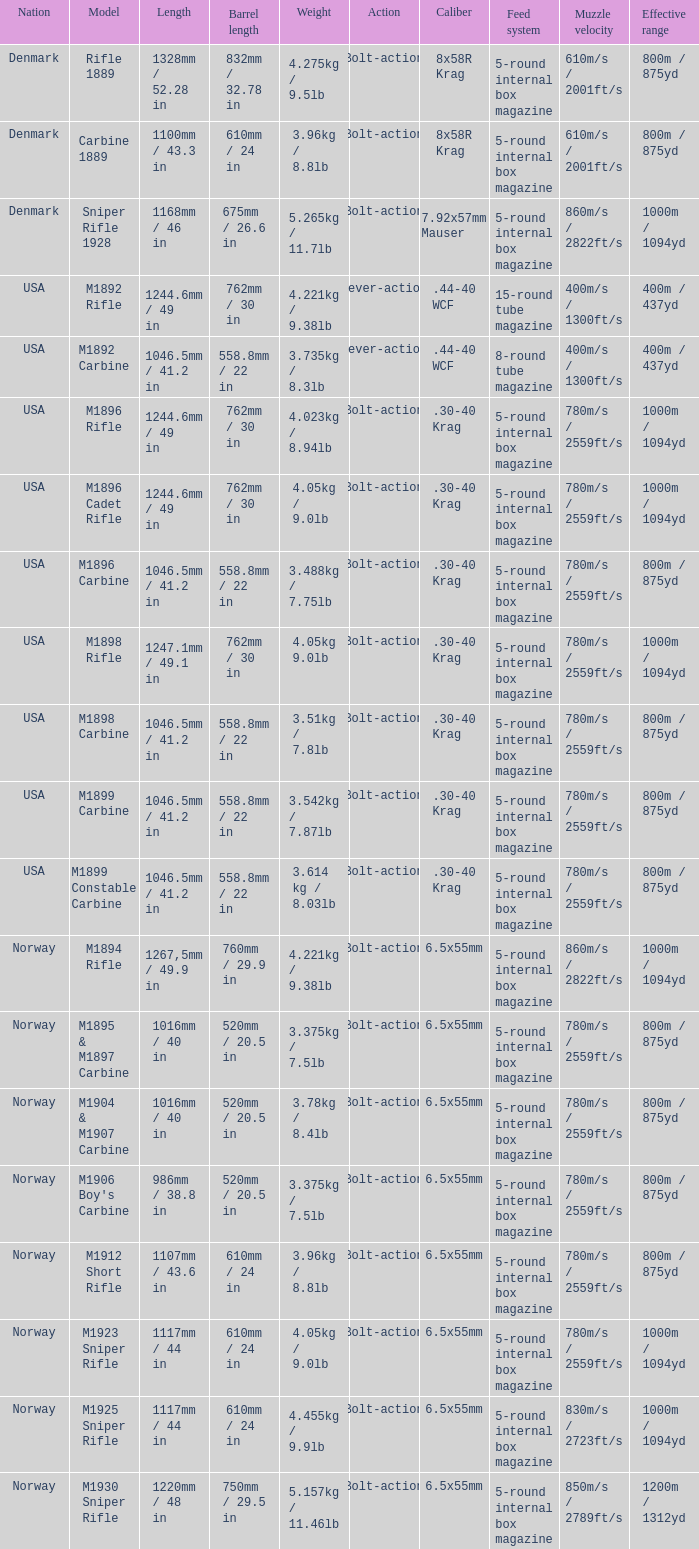What is Length, when Barrel Length is 750mm / 29.5 in? 1220mm / 48 in. 